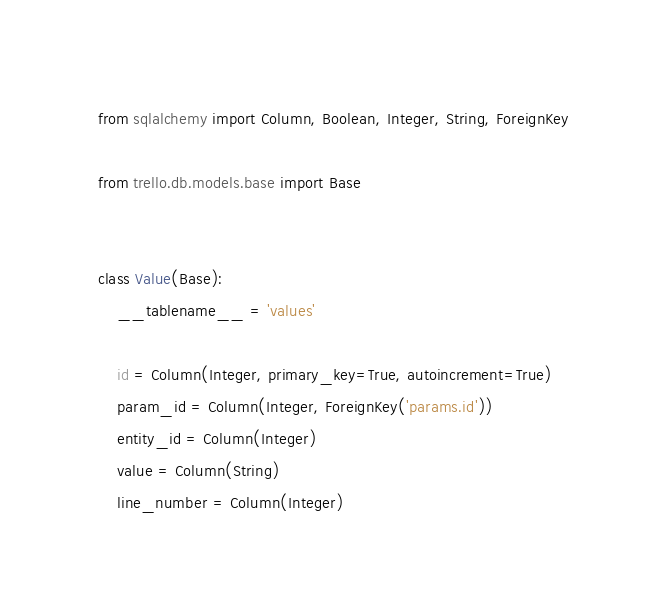<code> <loc_0><loc_0><loc_500><loc_500><_Python_>from sqlalchemy import Column, Boolean, Integer, String, ForeignKey

from trello.db.models.base import Base


class Value(Base):
    __tablename__ = 'values'

    id = Column(Integer, primary_key=True, autoincrement=True)
    param_id = Column(Integer, ForeignKey('params.id'))
    entity_id = Column(Integer)
    value = Column(String)
    line_number = Column(Integer)
</code> 